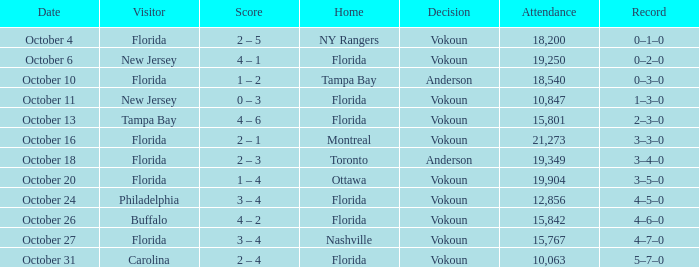What was the score on October 31? 2 – 4. 